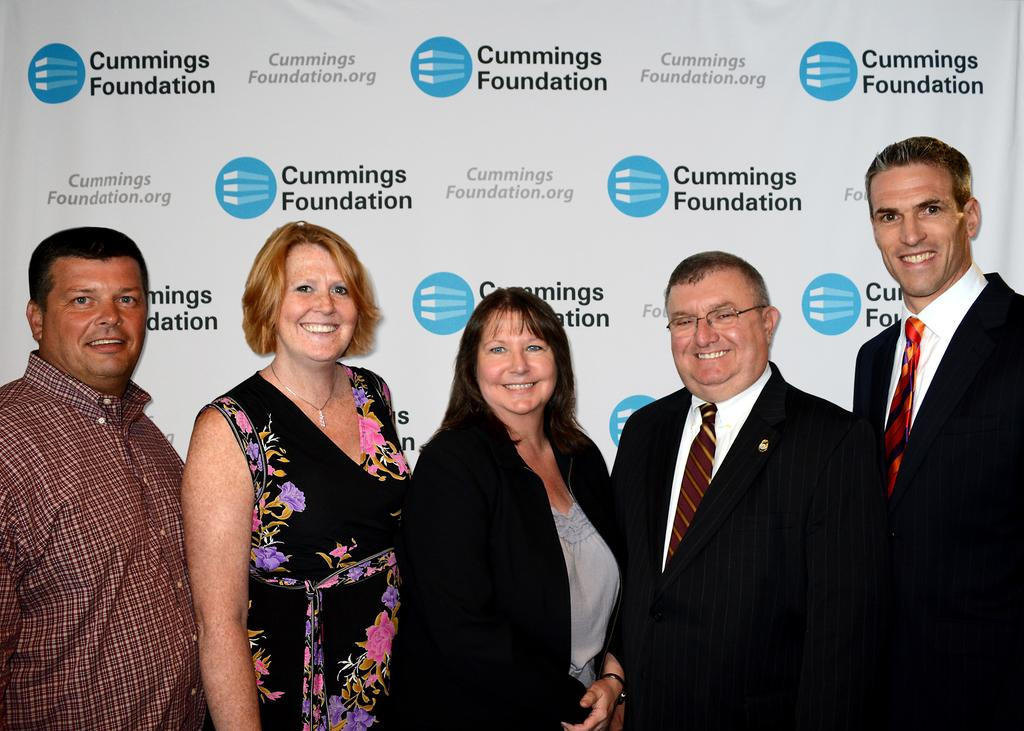How many people are present in the image? There are 5 people standing in the image. What are two of the people wearing? Two of the people are wearing suits. What can be seen on the wall in the image? There is a poster visible in the image. What is written on the poster? The poster has the text "cummings foundation" written on it. How much income does the bag hanging on the wall generate in the image? There is no bag hanging on the wall in the image, so it is not possible to determine its income. 